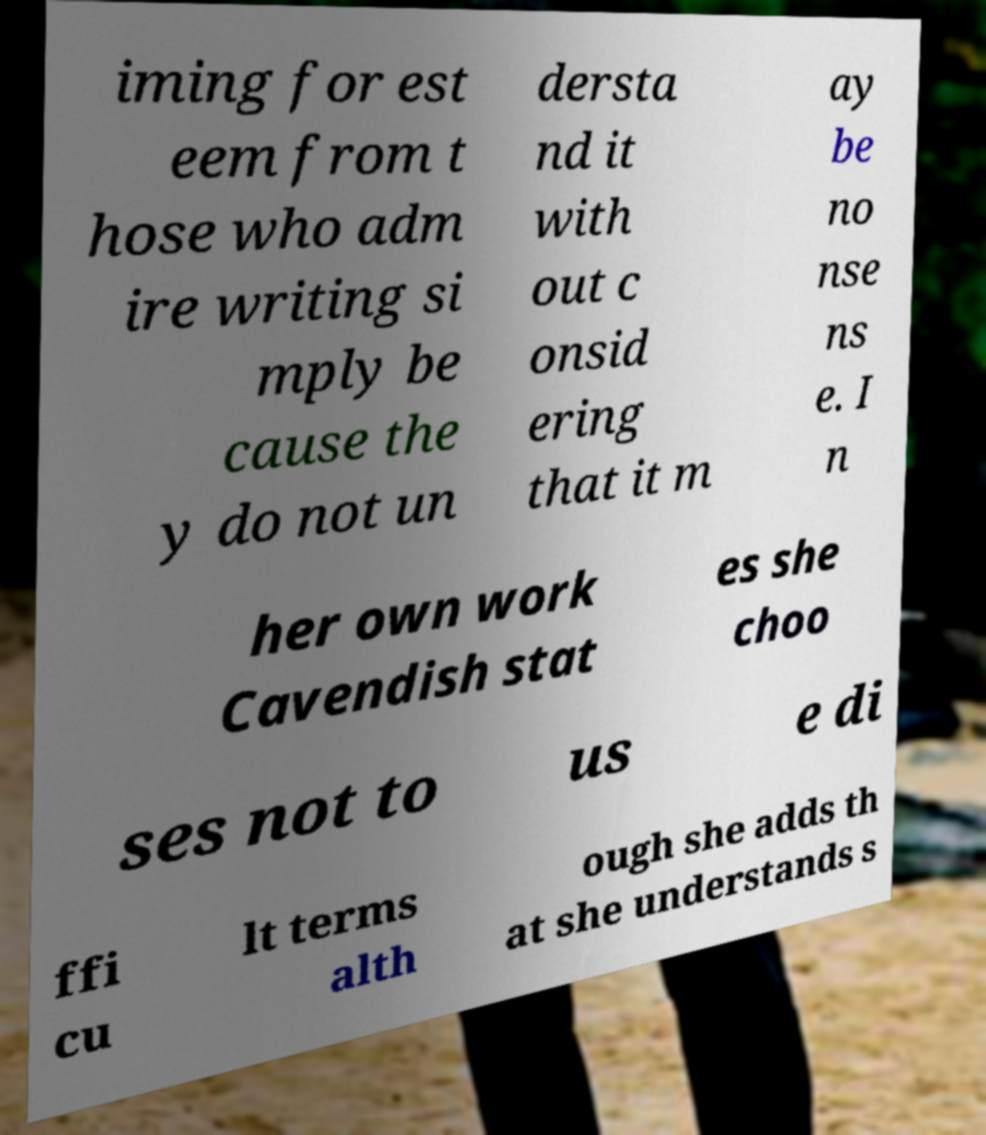Can you accurately transcribe the text from the provided image for me? iming for est eem from t hose who adm ire writing si mply be cause the y do not un dersta nd it with out c onsid ering that it m ay be no nse ns e. I n her own work Cavendish stat es she choo ses not to us e di ffi cu lt terms alth ough she adds th at she understands s 